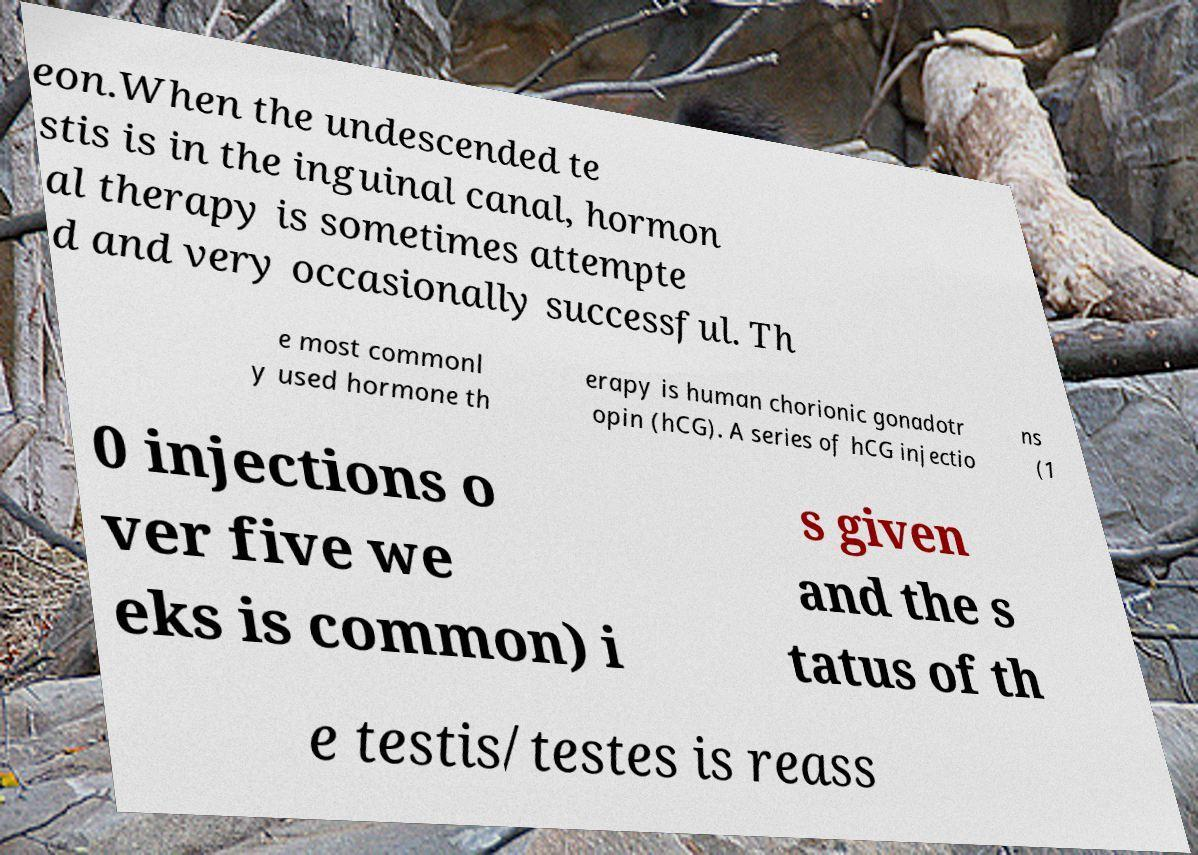Could you extract and type out the text from this image? eon.When the undescended te stis is in the inguinal canal, hormon al therapy is sometimes attempte d and very occasionally successful. Th e most commonl y used hormone th erapy is human chorionic gonadotr opin (hCG). A series of hCG injectio ns (1 0 injections o ver five we eks is common) i s given and the s tatus of th e testis/testes is reass 